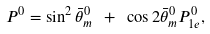Convert formula to latex. <formula><loc_0><loc_0><loc_500><loc_500>P ^ { 0 } = \sin ^ { 2 } \bar { \theta } ^ { 0 } _ { m } \ + \ \cos 2 \bar { \theta } ^ { 0 } _ { m } P ^ { 0 } _ { 1 e } ,</formula> 